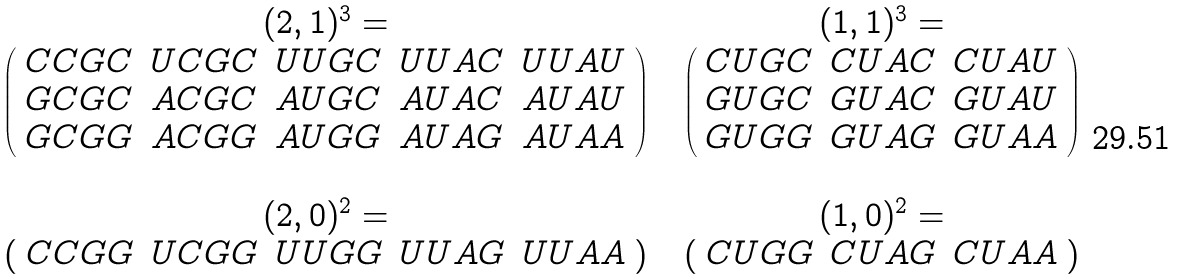Convert formula to latex. <formula><loc_0><loc_0><loc_500><loc_500>\begin{array} { c c c } ( 2 , 1 ) ^ { 3 } = & & ( 1 , 1 ) ^ { 3 } = \\ \left ( \begin{array} { c c c c c } C C G C & U C G C & U U G C & U U A C & U U A U \\ G C G C & A C G C & A U G C & A U A C & A U A U \\ G C G G & A C G G & A U G G & A U A G & A U A A \\ \end{array} \right ) & & \left ( \begin{array} { c c c c c } C U G C & C U A C & C U A U \\ G U G C & G U A C & G U A U \\ G U G G & G U A G & G U A A \\ \end{array} \right ) \\ & & \\ ( 2 , 0 ) ^ { 2 } = & & ( 1 , 0 ) ^ { 2 } = \\ \left ( \begin{array} { c c c c c } C C G G & U C G G & U U G G & U U A G & U U A A \\ \end{array} \right ) & & \left ( \begin{array} { c c c c c } C U G G & C U A G & C U A A \\ \end{array} \right ) \\ \end{array}</formula> 